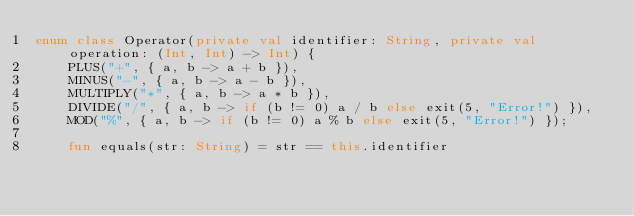<code> <loc_0><loc_0><loc_500><loc_500><_Kotlin_>enum class Operator(private val identifier: String, private val operation: (Int, Int) -> Int) {
    PLUS("+", { a, b -> a + b }),
    MINUS("-", { a, b -> a - b }),
    MULTIPLY("*", { a, b -> a * b }),
    DIVIDE("/", { a, b -> if (b != 0) a / b else exit(5, "Error!") }),
    MOD("%", { a, b -> if (b != 0) a % b else exit(5, "Error!") });

    fun equals(str: String) = str == this.identifier
</code> 